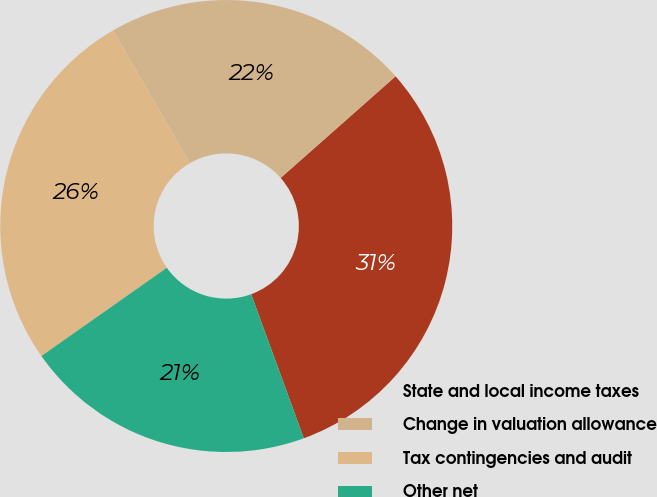Convert chart. <chart><loc_0><loc_0><loc_500><loc_500><pie_chart><fcel>State and local income taxes<fcel>Change in valuation allowance<fcel>Tax contingencies and audit<fcel>Other net<nl><fcel>30.95%<fcel>21.83%<fcel>26.4%<fcel>20.82%<nl></chart> 